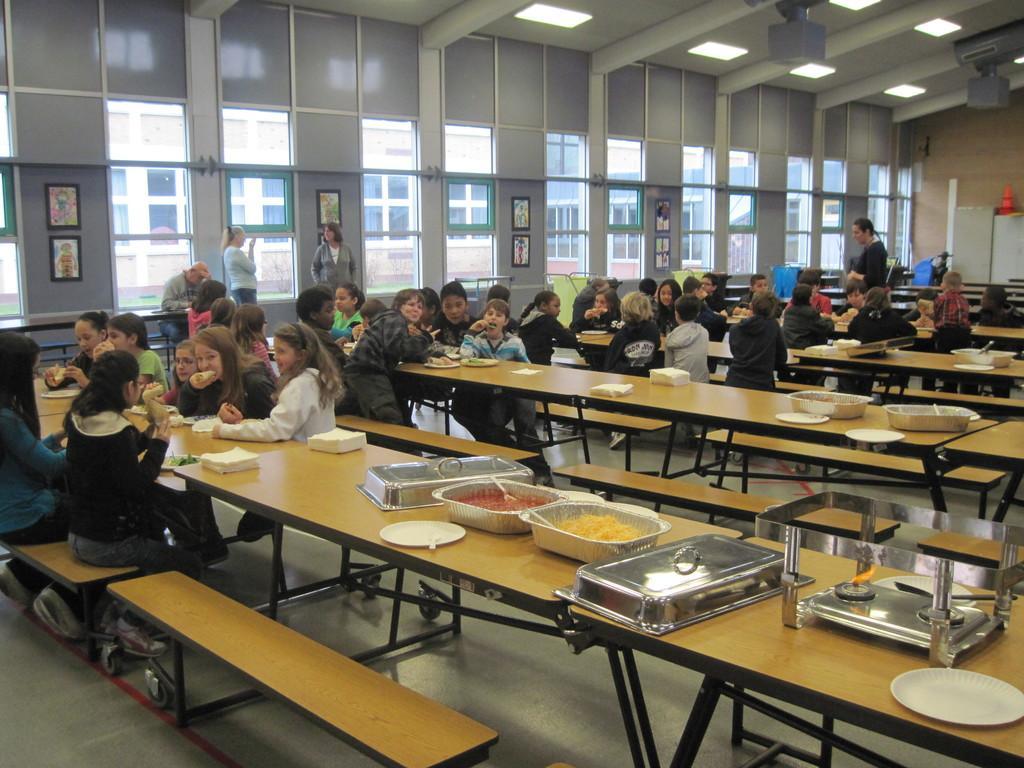Could you give a brief overview of what you see in this image? In this image it seems like a mess in which students are sitting on the bench and eating the food. On the table there are different dishes which are kept in bowl. At the top there is light. At the background there are photo frames,windows. The children are eating the food which is kept on the table. At the right top corner there's a wall and cupboards. 